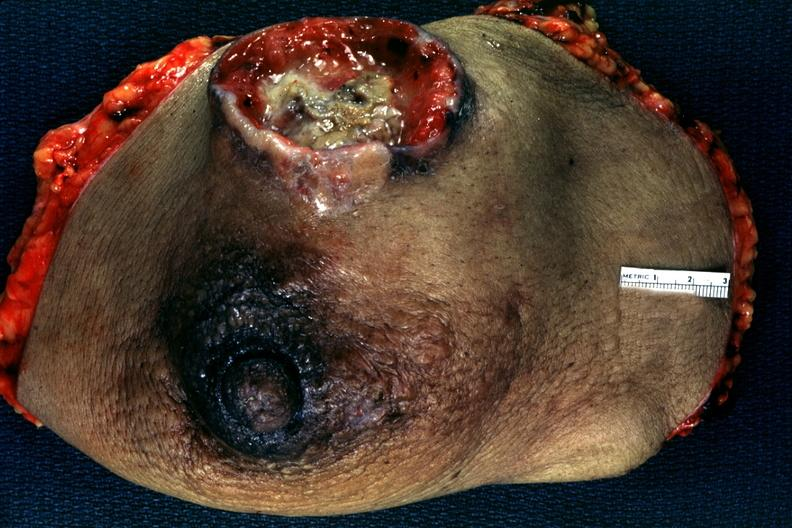s leiomyosarcoma present?
Answer the question using a single word or phrase. No 